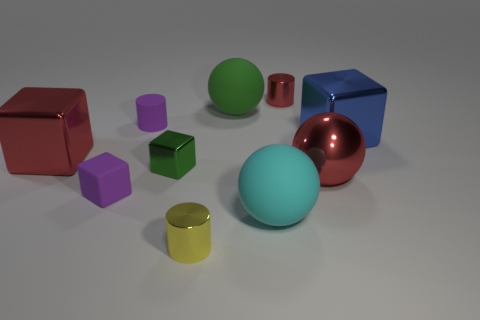Could you guess the purpose of arranging these objects? The arrangement of geometric objects seems to suggest a setup for either a visual study in shapes and colors, or perhaps a simplistic render test for 3D modeling software, where lighting and texture effects can be evaluated. 